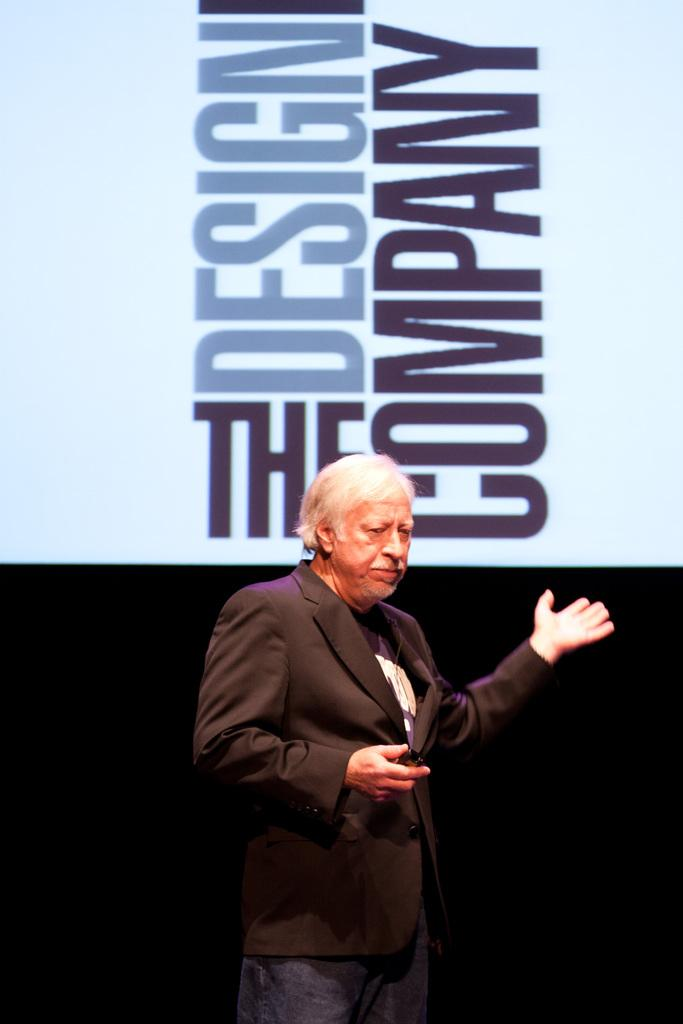<image>
Share a concise interpretation of the image provided. A white haired man stands in front of a large sign that says "The Design Company" 